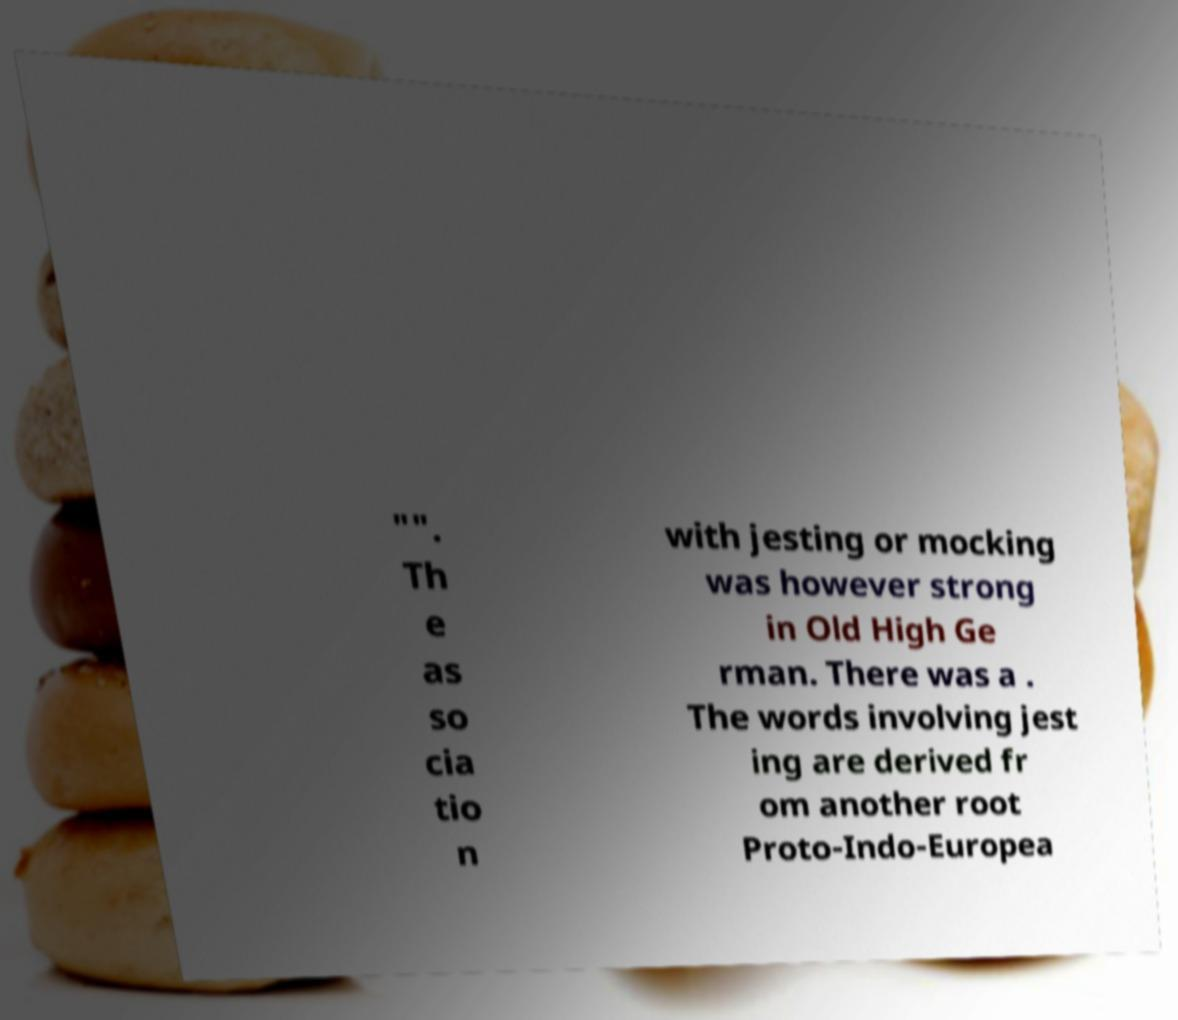Could you extract and type out the text from this image? "". Th e as so cia tio n with jesting or mocking was however strong in Old High Ge rman. There was a . The words involving jest ing are derived fr om another root Proto-Indo-Europea 